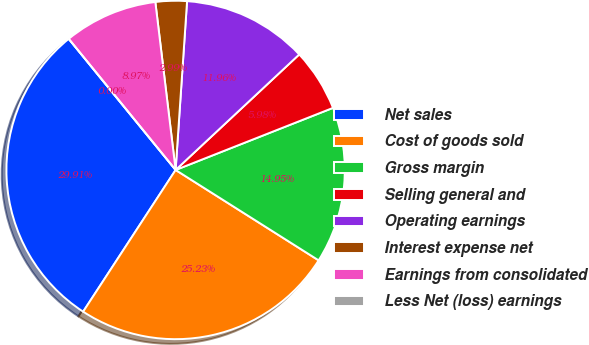<chart> <loc_0><loc_0><loc_500><loc_500><pie_chart><fcel>Net sales<fcel>Cost of goods sold<fcel>Gross margin<fcel>Selling general and<fcel>Operating earnings<fcel>Interest expense net<fcel>Earnings from consolidated<fcel>Less Net (loss) earnings<nl><fcel>29.91%<fcel>25.23%<fcel>14.95%<fcel>5.98%<fcel>11.96%<fcel>2.99%<fcel>8.97%<fcel>0.0%<nl></chart> 